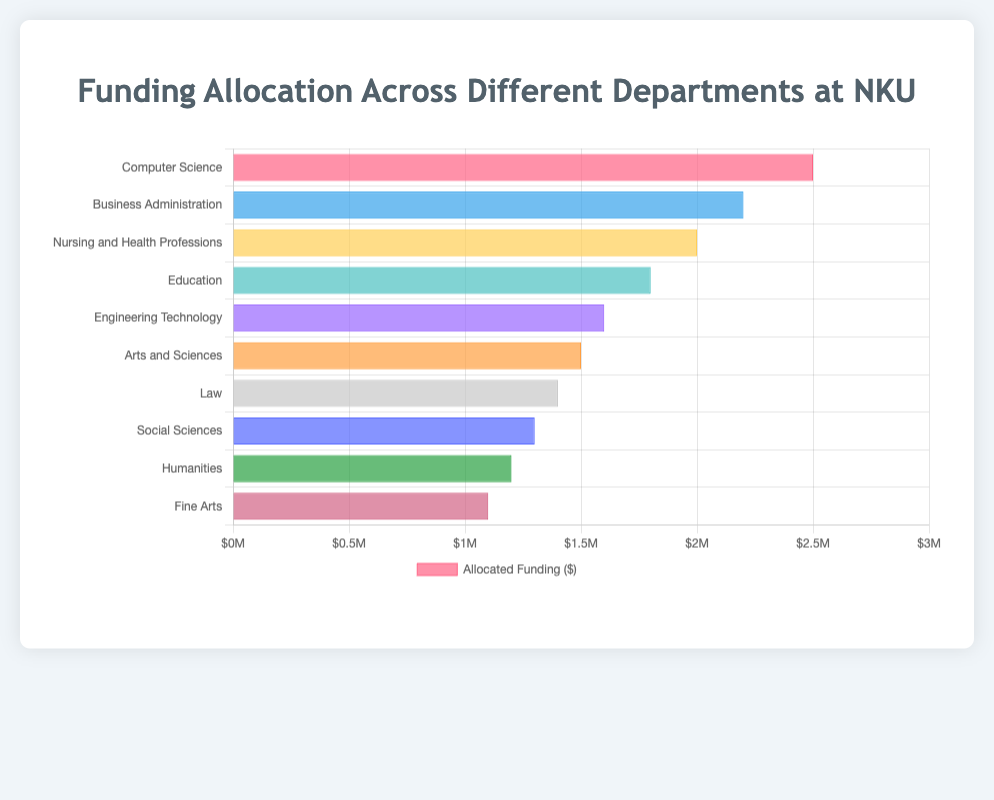Which department received the highest funding allocation? By observing the length of the bars, the department with the longest bar represents the highest funding. In this case, the Computer Science department has the longest bar.
Answer: Computer Science Which department has a shorter funding allocation, Education or Business Administration? Comparing the lengths of the bars for Education and Business Administration, the Business Administration bar is longer than the Education bar, indicating that Education has a shorter funding allocation.
Answer: Education How much more funding did the Computer Science department receive compared to Fine Arts? The funding for Computer Science is $2,500,000 and for Fine Arts is $1,100,000. The difference is $2,500,000 - $1,100,000 = $1,400,000.
Answer: $1,400,000 What is the combined funding for the Nursing and Health Professions, and Engineering Technology departments? The funding for Nursing and Health Professions is $2,000,000 and for Engineering Technology is $1,600,000. The combined funding is $2,000,000 + $1,600,000 = $3,600,000.
Answer: $3,600,000 Which department received the least funding allocation? The department with the shortest bar represents the least funding allocation, which is Fine Arts in this case.
Answer: Fine Arts Estimate the total funding allocated to all departments. Adding all the funding amounts: $2,500,000 + $2,200,000 + $2,000,000 + $1,800,000 + $1,600,000 + $1,500,000 + $1,400,000 + $1,300,000 + $1,200,000 + $1,100,000 = $16,600,000.
Answer: $16,600,000 Compare the funding of Law and Social Sciences. Which has more, and by how much? Law received $1,400,000, and Social Sciences received $1,300,000. Law has $1,400,000 - $1,300,000 = $100,000 more.
Answer: Law, $100,000 more What is the average funding allocated across all departments? The total funding is $16,600,000 for 10 departments. The average is $16,600,000 / 10 = $1,660,000.
Answer: $1,660,000 What is the median funding allocation among the departments? Ordering the funding amounts: $1,100,000, $1,200,000, $1,300,000, $1,400,000, $1,500,000, $1,600,000, $1,800,000, $2,000,000, $2,200,000, $2,500,000. The median is the average of the 5th and 6th values: ($1,500,000 + $1,600,000) / 2 = $1,550,000.
Answer: $1,550,000 